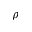<formula> <loc_0><loc_0><loc_500><loc_500>\rho</formula> 